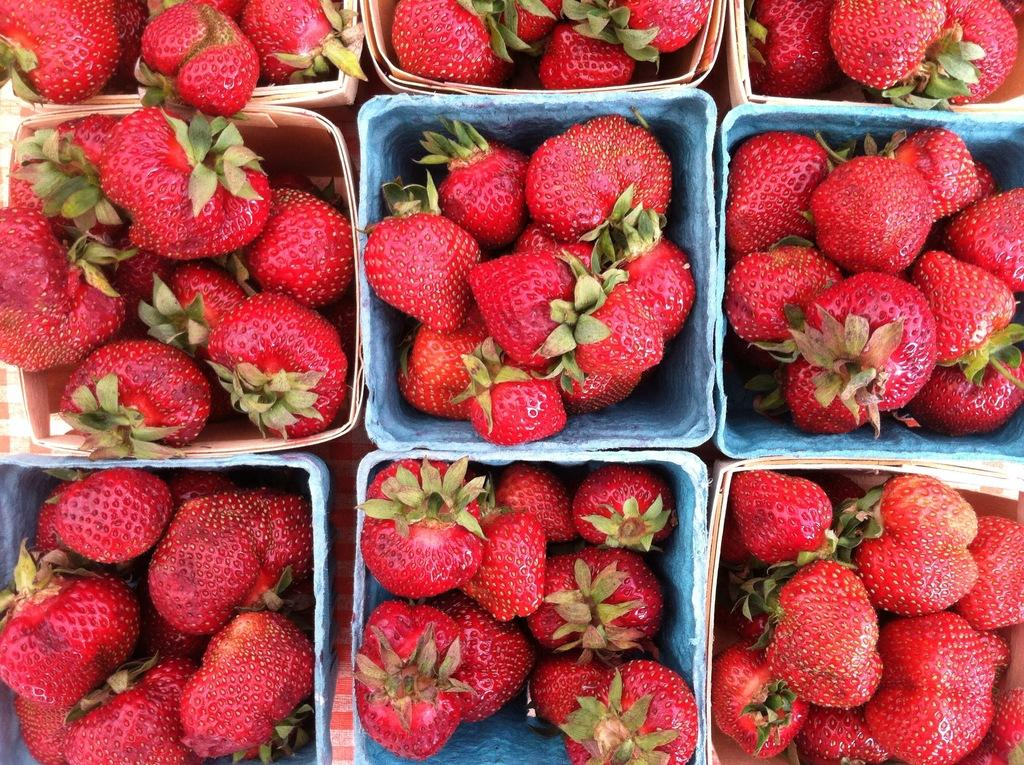What type of fruit is present in the image? There are strawberries in the image. What is the color of the strawberries? The strawberries are red in color. How are the strawberries arranged in the image? The strawberries are arranged in boxes. Where are the boxes with strawberries located? The boxes with strawberries are on a table. What type of tool is used to gather the strawberries in the image? There is no tool present in the image, and the strawberries are already arranged in boxes. 